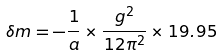Convert formula to latex. <formula><loc_0><loc_0><loc_500><loc_500>\delta m = - \frac { 1 } { a } \times \frac { g ^ { 2 } } { 1 2 \pi ^ { 2 } } \times 1 9 . 9 5</formula> 